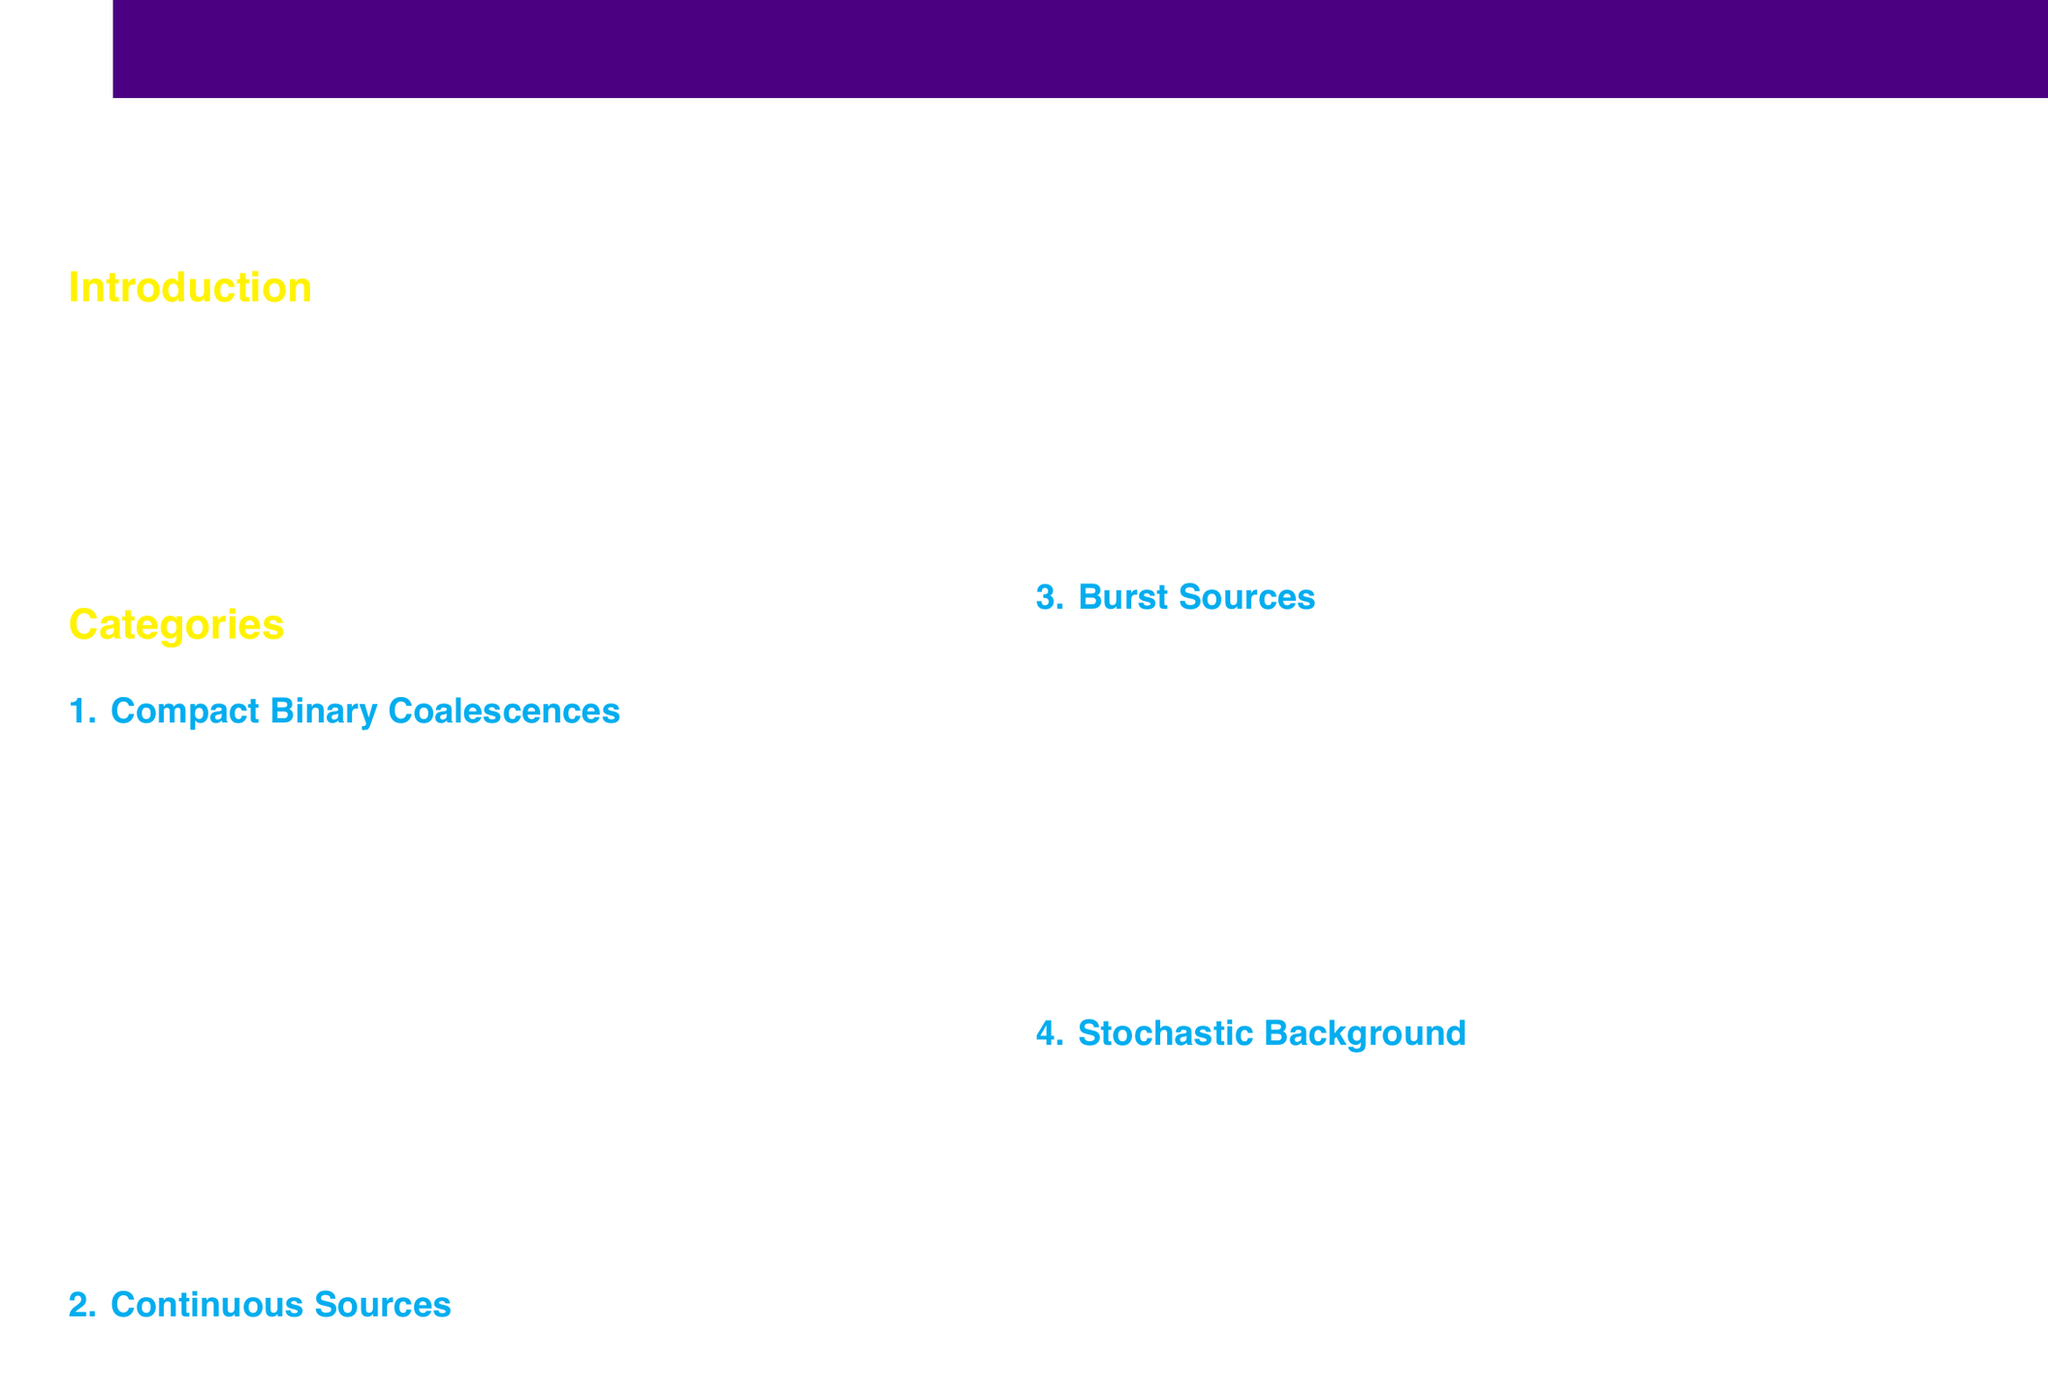What is the highest detection probability category? The document categorizes compact binary coalescences as having the highest detection probability among astrophysical sources of gravitational waves.
Answer: Compact Binary Coalescences What example is given for binary neutron star mergers? The catalog provides GW170817 as an example of a binary neutron star merger.
Answer: GW170817 What is the detection probability of rotating neutron stars? According to the document, the detection probability of rotating neutron stars is classified as low-medium.
Answer: Low-Medium Which type of gravitational wave source has very low detection probability? The document lists cosmic string cusps as a burst source with very low detection probability.
Answer: Cosmic String Cusps What is the classification of primordial gravitational waves from the early universe? The document classifies primordial gravitational waves from the early universe under stochastic background sources.
Answer: Stochastic Background What is the example provided for unresolved compact binary mergers? The document cites LIGO/Virgo upper limits as an example of unresolved compact binary mergers.
Answer: LIGO/Virgo upper limits What is the detection probability for black hole-neutron star mergers? The document classifies the detection probability for black hole-neutron star mergers as medium.
Answer: Medium What type of source is associated with the example SN 1987A? The document associates SN 1987A with core-collapse supernovae under burst sources.
Answer: Core-Collapse Supernovae What type of gravitational wave sources are continuous sources? Continuous sources are identified in the document as persistent, nearly monochromatic gravitational wave signals.
Answer: Persistent, nearly monochromatic GW signals 